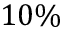Convert formula to latex. <formula><loc_0><loc_0><loc_500><loc_500>1 0 \%</formula> 